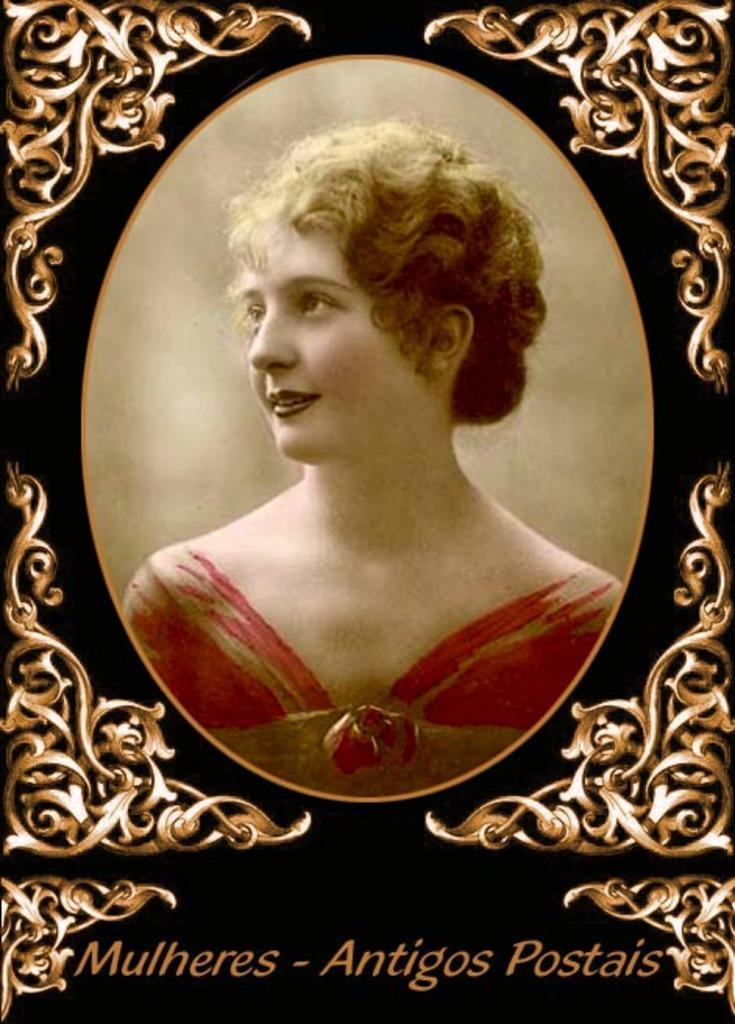Who is the main subject in the image? There is a woman in the middle of the image. What is located at the bottom of the image? There is text at the bottom of the image. What type of object is the image contained within? The image is a photo frame. What type of fruit is being used to create the photo frame in the image? There is no fruit present in the image, and the photo frame is not made of fruit. 